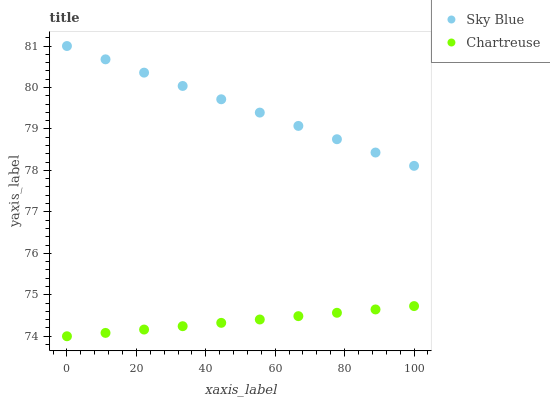Does Chartreuse have the minimum area under the curve?
Answer yes or no. Yes. Does Sky Blue have the maximum area under the curve?
Answer yes or no. Yes. Does Chartreuse have the maximum area under the curve?
Answer yes or no. No. Is Chartreuse the smoothest?
Answer yes or no. Yes. Is Sky Blue the roughest?
Answer yes or no. Yes. Is Chartreuse the roughest?
Answer yes or no. No. Does Chartreuse have the lowest value?
Answer yes or no. Yes. Does Sky Blue have the highest value?
Answer yes or no. Yes. Does Chartreuse have the highest value?
Answer yes or no. No. Is Chartreuse less than Sky Blue?
Answer yes or no. Yes. Is Sky Blue greater than Chartreuse?
Answer yes or no. Yes. Does Chartreuse intersect Sky Blue?
Answer yes or no. No. 